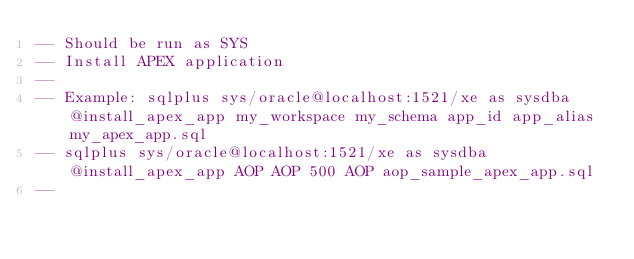Convert code to text. <code><loc_0><loc_0><loc_500><loc_500><_SQL_>-- Should be run as SYS
-- Install APEX application
--
-- Example: sqlplus sys/oracle@localhost:1521/xe as sysdba @install_apex_app my_workspace my_schema app_id app_alias my_apex_app.sql
-- sqlplus sys/oracle@localhost:1521/xe as sysdba @install_apex_app AOP AOP 500 AOP aop_sample_apex_app.sql
--</code> 